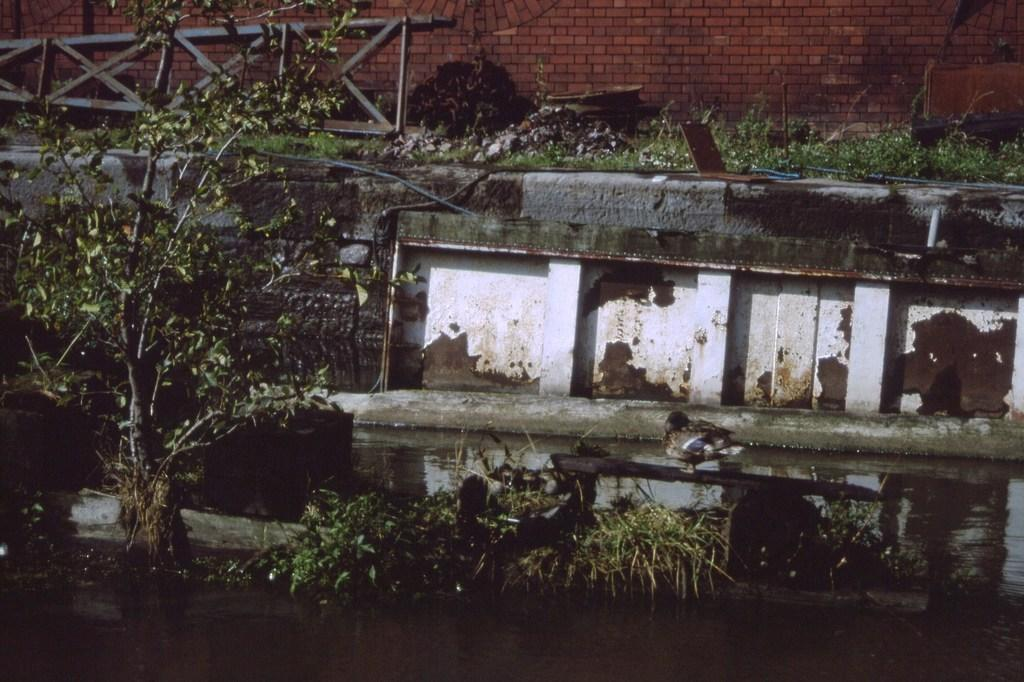What type of living organisms can be seen in the image? Plants can be seen in the image. What is located at the bottom of the image? There is water at the bottom of the image. What can be seen in the middle of the image? There is a bird standing on a stick in the middle of the image. What is visible in the background of the image? There is a wall in the background of the image. How many hands can be seen holding the balls in the image? There are no hands or balls present in the image. 